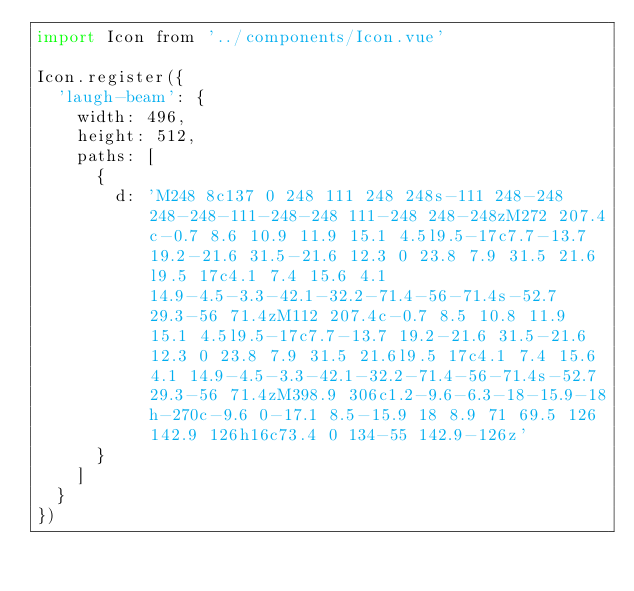<code> <loc_0><loc_0><loc_500><loc_500><_JavaScript_>import Icon from '../components/Icon.vue'

Icon.register({
  'laugh-beam': {
    width: 496,
    height: 512,
    paths: [
      {
        d: 'M248 8c137 0 248 111 248 248s-111 248-248 248-248-111-248-248 111-248 248-248zM272 207.4c-0.7 8.6 10.9 11.9 15.1 4.5l9.5-17c7.7-13.7 19.2-21.6 31.5-21.6 12.3 0 23.8 7.9 31.5 21.6l9.5 17c4.1 7.4 15.6 4.1 14.9-4.5-3.3-42.1-32.2-71.4-56-71.4s-52.7 29.3-56 71.4zM112 207.4c-0.7 8.5 10.8 11.9 15.1 4.5l9.5-17c7.7-13.7 19.2-21.6 31.5-21.6 12.3 0 23.8 7.9 31.5 21.6l9.5 17c4.1 7.4 15.6 4.1 14.9-4.5-3.3-42.1-32.2-71.4-56-71.4s-52.7 29.3-56 71.4zM398.9 306c1.2-9.6-6.3-18-15.9-18h-270c-9.6 0-17.1 8.5-15.9 18 8.9 71 69.5 126 142.9 126h16c73.4 0 134-55 142.9-126z'
      }
    ]
  }
})
</code> 